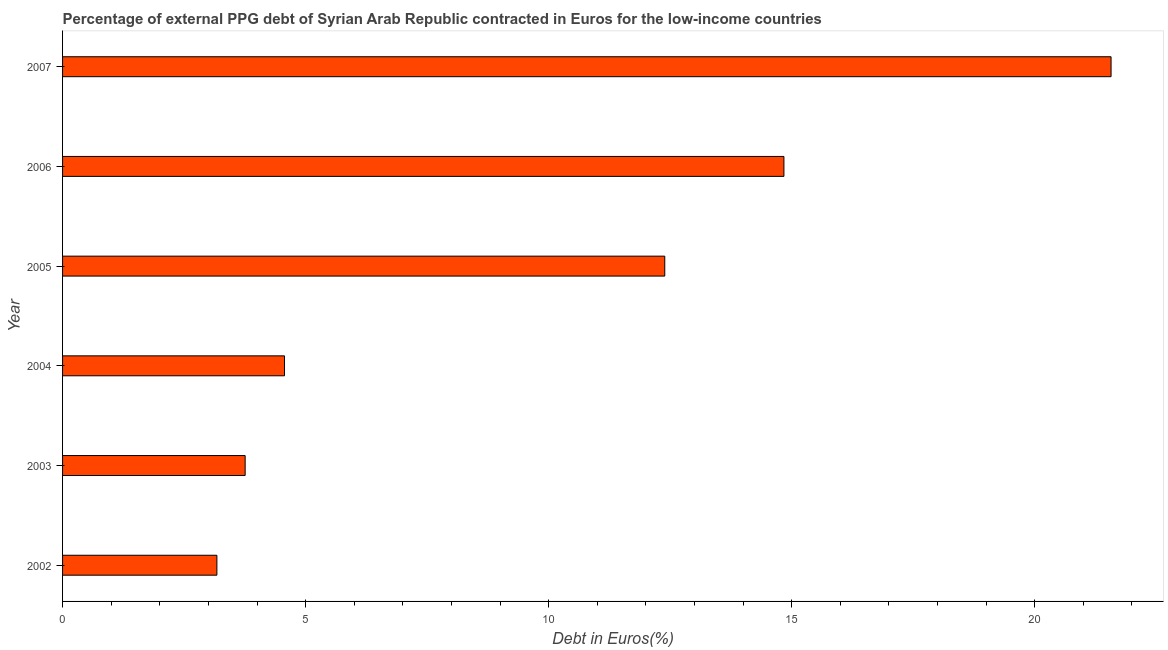What is the title of the graph?
Make the answer very short. Percentage of external PPG debt of Syrian Arab Republic contracted in Euros for the low-income countries. What is the label or title of the X-axis?
Your response must be concise. Debt in Euros(%). What is the currency composition of ppg debt in 2003?
Offer a very short reply. 3.76. Across all years, what is the maximum currency composition of ppg debt?
Make the answer very short. 21.57. Across all years, what is the minimum currency composition of ppg debt?
Keep it short and to the point. 3.17. In which year was the currency composition of ppg debt minimum?
Provide a succinct answer. 2002. What is the sum of the currency composition of ppg debt?
Ensure brevity in your answer.  60.29. What is the difference between the currency composition of ppg debt in 2004 and 2007?
Make the answer very short. -17. What is the average currency composition of ppg debt per year?
Offer a very short reply. 10.05. What is the median currency composition of ppg debt?
Your answer should be very brief. 8.48. What is the ratio of the currency composition of ppg debt in 2006 to that in 2007?
Your answer should be very brief. 0.69. Is the currency composition of ppg debt in 2004 less than that in 2005?
Your answer should be compact. Yes. What is the difference between the highest and the second highest currency composition of ppg debt?
Offer a very short reply. 6.73. Is the sum of the currency composition of ppg debt in 2004 and 2007 greater than the maximum currency composition of ppg debt across all years?
Provide a succinct answer. Yes. What is the difference between the highest and the lowest currency composition of ppg debt?
Ensure brevity in your answer.  18.39. How many bars are there?
Make the answer very short. 6. Are all the bars in the graph horizontal?
Your answer should be compact. Yes. How many years are there in the graph?
Offer a very short reply. 6. What is the difference between two consecutive major ticks on the X-axis?
Make the answer very short. 5. What is the Debt in Euros(%) of 2002?
Make the answer very short. 3.17. What is the Debt in Euros(%) of 2003?
Keep it short and to the point. 3.76. What is the Debt in Euros(%) in 2004?
Give a very brief answer. 4.57. What is the Debt in Euros(%) in 2005?
Your response must be concise. 12.39. What is the Debt in Euros(%) of 2006?
Offer a terse response. 14.84. What is the Debt in Euros(%) of 2007?
Give a very brief answer. 21.57. What is the difference between the Debt in Euros(%) in 2002 and 2003?
Offer a very short reply. -0.58. What is the difference between the Debt in Euros(%) in 2002 and 2004?
Your answer should be compact. -1.39. What is the difference between the Debt in Euros(%) in 2002 and 2005?
Make the answer very short. -9.21. What is the difference between the Debt in Euros(%) in 2002 and 2006?
Ensure brevity in your answer.  -11.66. What is the difference between the Debt in Euros(%) in 2002 and 2007?
Give a very brief answer. -18.39. What is the difference between the Debt in Euros(%) in 2003 and 2004?
Make the answer very short. -0.81. What is the difference between the Debt in Euros(%) in 2003 and 2005?
Provide a succinct answer. -8.63. What is the difference between the Debt in Euros(%) in 2003 and 2006?
Ensure brevity in your answer.  -11.08. What is the difference between the Debt in Euros(%) in 2003 and 2007?
Make the answer very short. -17.81. What is the difference between the Debt in Euros(%) in 2004 and 2005?
Make the answer very short. -7.82. What is the difference between the Debt in Euros(%) in 2004 and 2006?
Make the answer very short. -10.27. What is the difference between the Debt in Euros(%) in 2004 and 2007?
Your answer should be very brief. -17. What is the difference between the Debt in Euros(%) in 2005 and 2006?
Make the answer very short. -2.45. What is the difference between the Debt in Euros(%) in 2005 and 2007?
Give a very brief answer. -9.18. What is the difference between the Debt in Euros(%) in 2006 and 2007?
Provide a short and direct response. -6.73. What is the ratio of the Debt in Euros(%) in 2002 to that in 2003?
Offer a terse response. 0.84. What is the ratio of the Debt in Euros(%) in 2002 to that in 2004?
Provide a short and direct response. 0.69. What is the ratio of the Debt in Euros(%) in 2002 to that in 2005?
Keep it short and to the point. 0.26. What is the ratio of the Debt in Euros(%) in 2002 to that in 2006?
Your answer should be compact. 0.21. What is the ratio of the Debt in Euros(%) in 2002 to that in 2007?
Give a very brief answer. 0.15. What is the ratio of the Debt in Euros(%) in 2003 to that in 2004?
Keep it short and to the point. 0.82. What is the ratio of the Debt in Euros(%) in 2003 to that in 2005?
Offer a very short reply. 0.3. What is the ratio of the Debt in Euros(%) in 2003 to that in 2006?
Your answer should be very brief. 0.25. What is the ratio of the Debt in Euros(%) in 2003 to that in 2007?
Keep it short and to the point. 0.17. What is the ratio of the Debt in Euros(%) in 2004 to that in 2005?
Your response must be concise. 0.37. What is the ratio of the Debt in Euros(%) in 2004 to that in 2006?
Your response must be concise. 0.31. What is the ratio of the Debt in Euros(%) in 2004 to that in 2007?
Give a very brief answer. 0.21. What is the ratio of the Debt in Euros(%) in 2005 to that in 2006?
Keep it short and to the point. 0.83. What is the ratio of the Debt in Euros(%) in 2005 to that in 2007?
Ensure brevity in your answer.  0.57. What is the ratio of the Debt in Euros(%) in 2006 to that in 2007?
Ensure brevity in your answer.  0.69. 